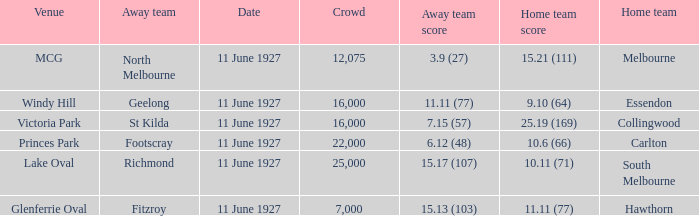Which home team competed against the away team Geelong? Essendon. 